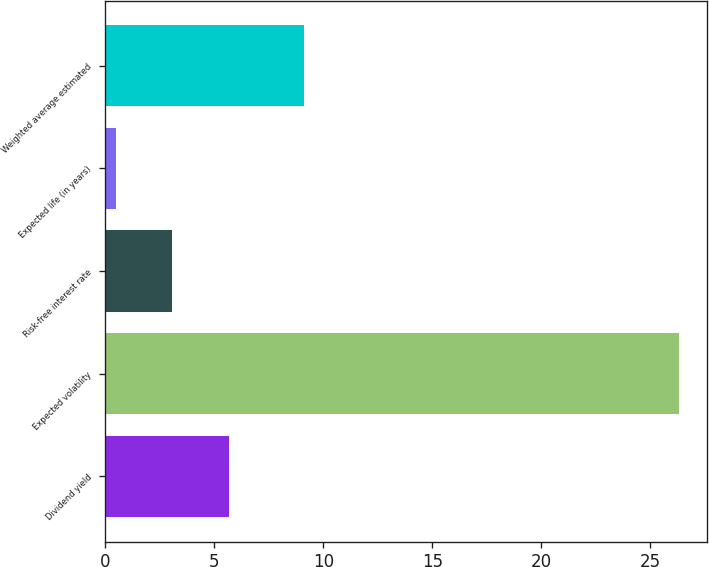<chart> <loc_0><loc_0><loc_500><loc_500><bar_chart><fcel>Dividend yield<fcel>Expected volatility<fcel>Risk-free interest rate<fcel>Expected life (in years)<fcel>Weighted average estimated<nl><fcel>5.66<fcel>26.3<fcel>3.08<fcel>0.5<fcel>9.14<nl></chart> 